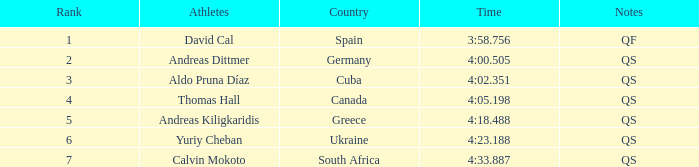What are the notes for the athlete from Spain? QF. 